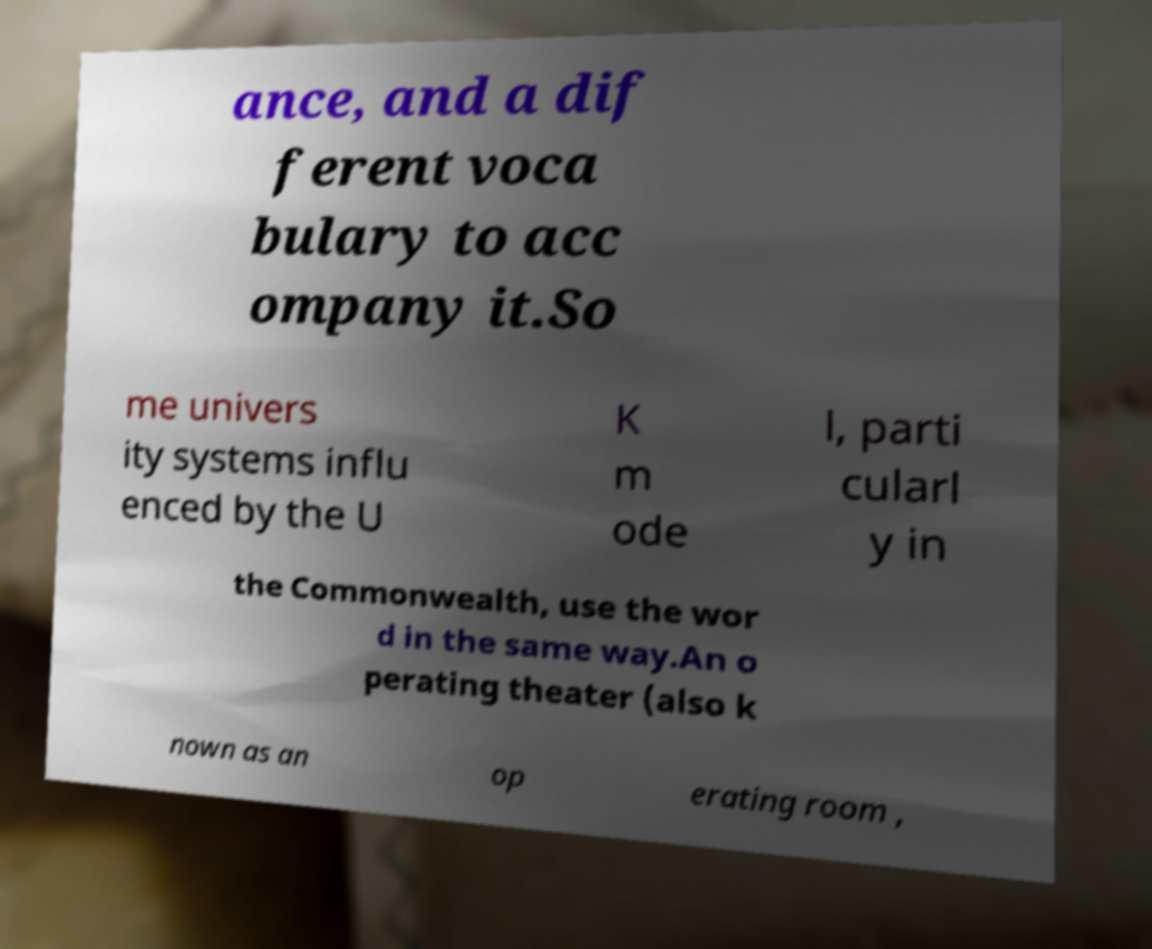What messages or text are displayed in this image? I need them in a readable, typed format. ance, and a dif ferent voca bulary to acc ompany it.So me univers ity systems influ enced by the U K m ode l, parti cularl y in the Commonwealth, use the wor d in the same way.An o perating theater (also k nown as an op erating room , 